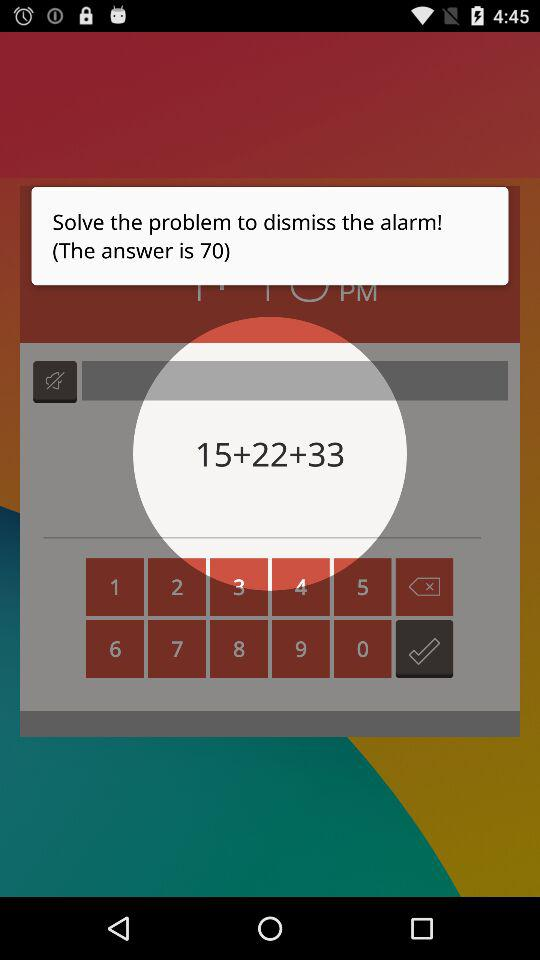What to do to dismiss the alarm? To dismiss the alarm, solve the problem. 